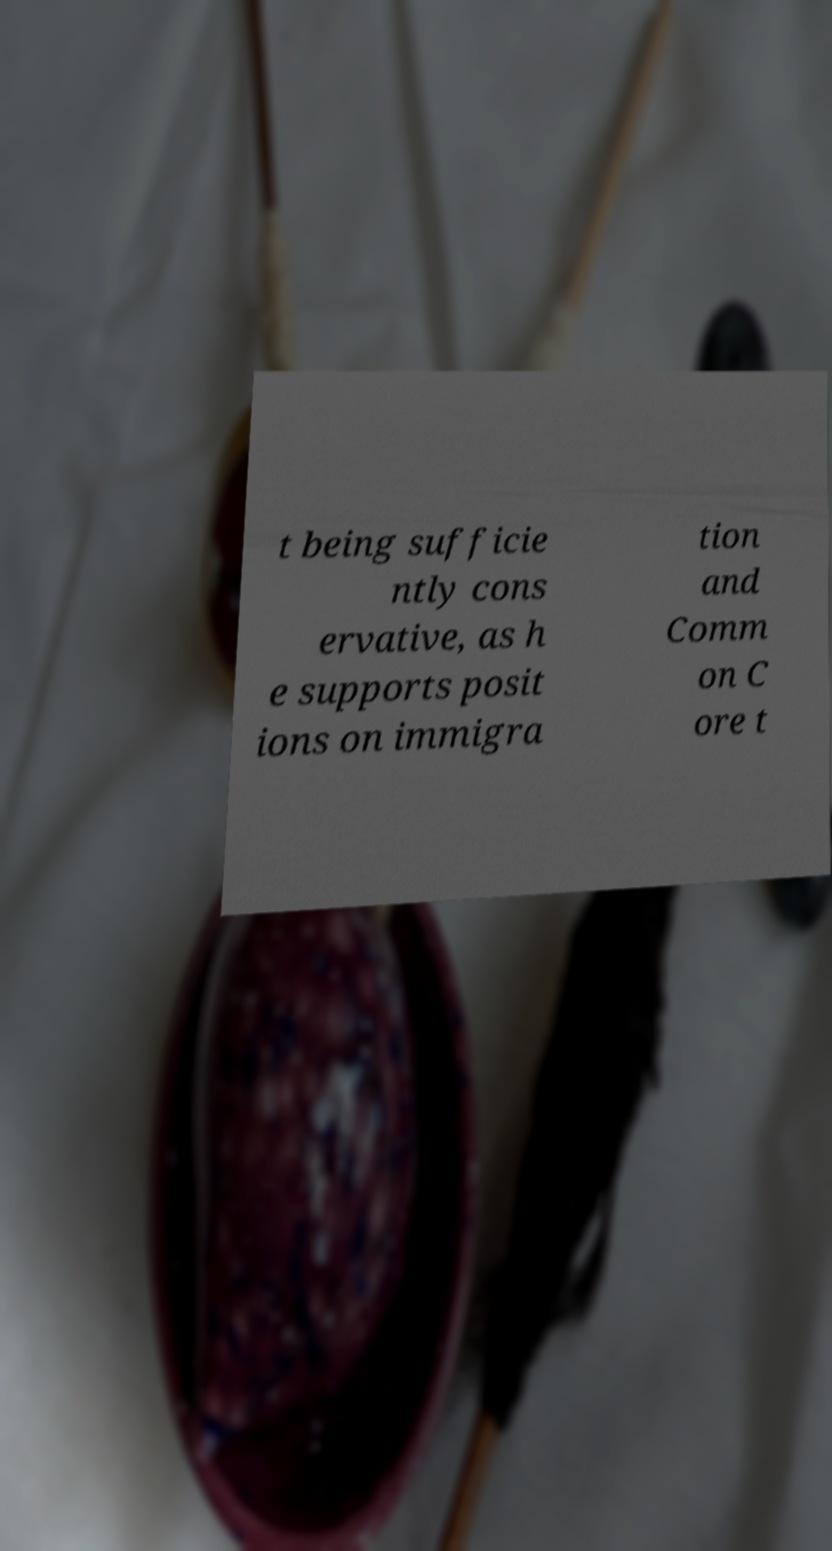Could you assist in decoding the text presented in this image and type it out clearly? t being sufficie ntly cons ervative, as h e supports posit ions on immigra tion and Comm on C ore t 